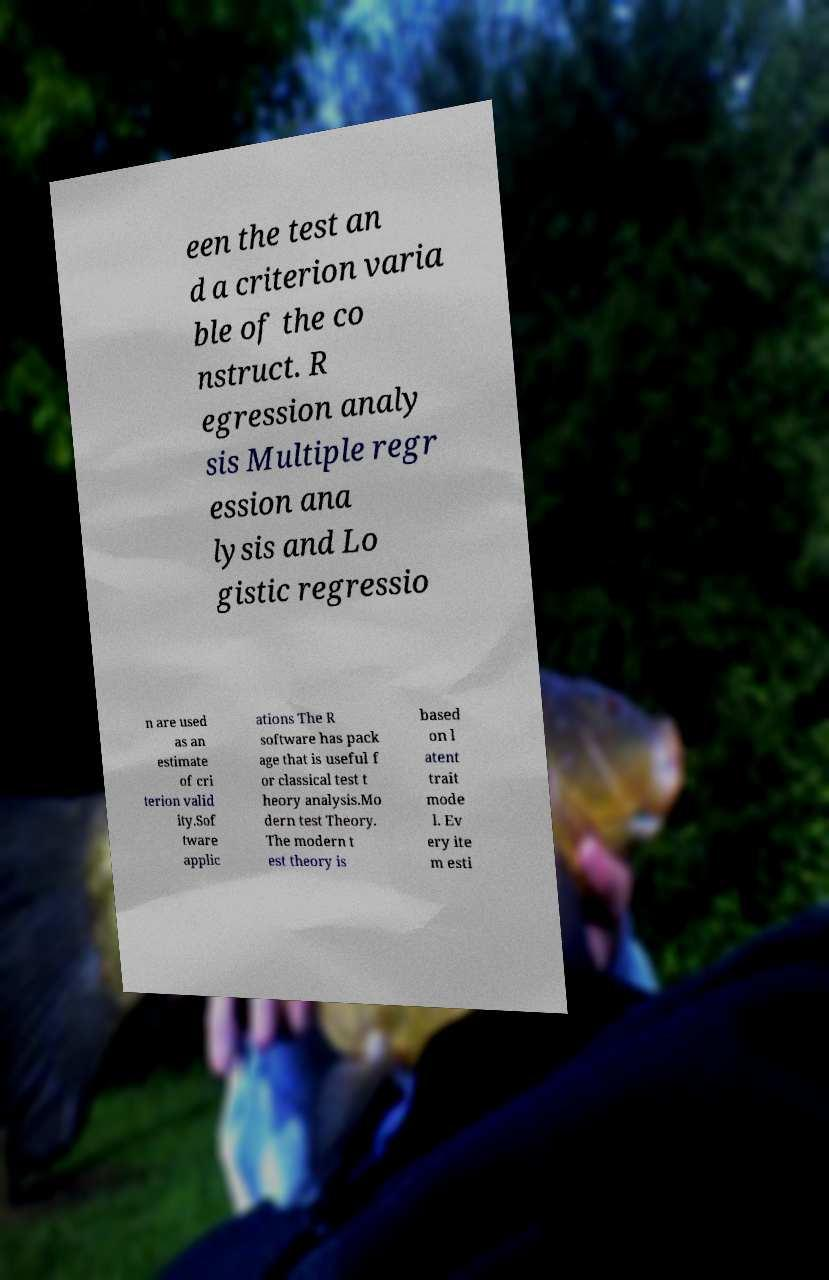Could you extract and type out the text from this image? een the test an d a criterion varia ble of the co nstruct. R egression analy sis Multiple regr ession ana lysis and Lo gistic regressio n are used as an estimate of cri terion valid ity.Sof tware applic ations The R software has pack age that is useful f or classical test t heory analysis.Mo dern test Theory. The modern t est theory is based on l atent trait mode l. Ev ery ite m esti 